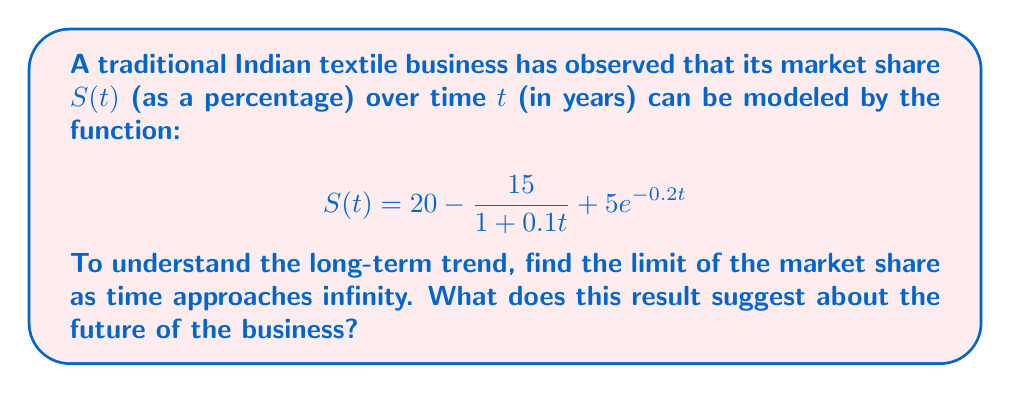Teach me how to tackle this problem. To find the long-term trend of the market share, we need to evaluate the limit of $S(t)$ as $t$ approaches infinity. Let's break down the function and analyze each part:

1) The constant term: $20$
   This remains unchanged as $t$ approaches infinity.

2) The rational term: $\frac{15}{1 + 0.1t}$
   As $t$ approaches infinity, the denominator grows much faster than the numerator.
   $$\lim_{t \to \infty} \frac{15}{1 + 0.1t} = 0$$

3) The exponential term: $5e^{-0.2t}$
   As $t$ approaches infinity, this term approaches zero:
   $$\lim_{t \to \infty} 5e^{-0.2t} = 0$$

Now, let's combine these results:

$$\begin{align}
\lim_{t \to \infty} S(t) &= \lim_{t \to \infty} \left(20 - \frac{15}{1 + 0.1t} + 5e^{-0.2t}\right) \\
&= 20 - 0 + 0 \\
&= 20
\end{align}$$

This means that in the long run, the market share of the business is expected to stabilize at 20%.
Answer: The limit of the market share as time approaches infinity is 20%. This suggests that the business is likely to establish a stable long-term market presence, capturing approximately one-fifth of the market share in the traditional Indian textile industry. 